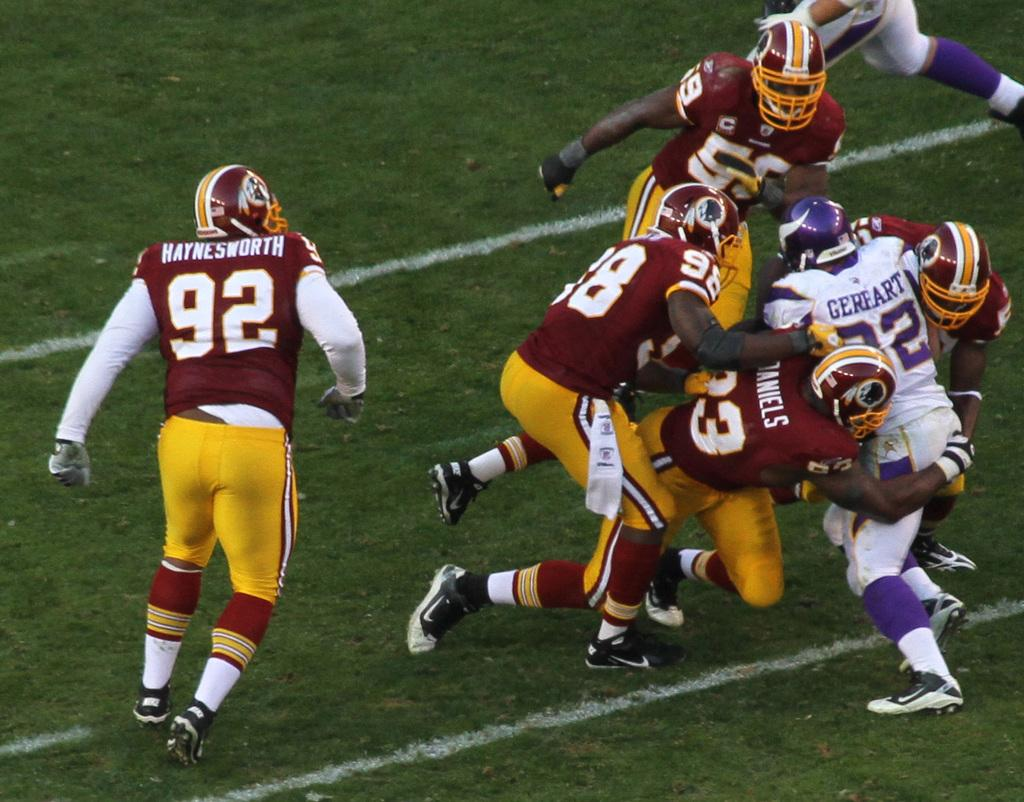Who or what is present in the image? There are people in the image. What are the people doing? The people are running. What protective gear are the people wearing? The people are wearing helmets. What type of environment can be seen in the background of the image? There is grass visible in the background of the image. How are the worms distributed among the chickens in the image? There are no worms or chickens present in the image; it features people running while wearing helmets. 